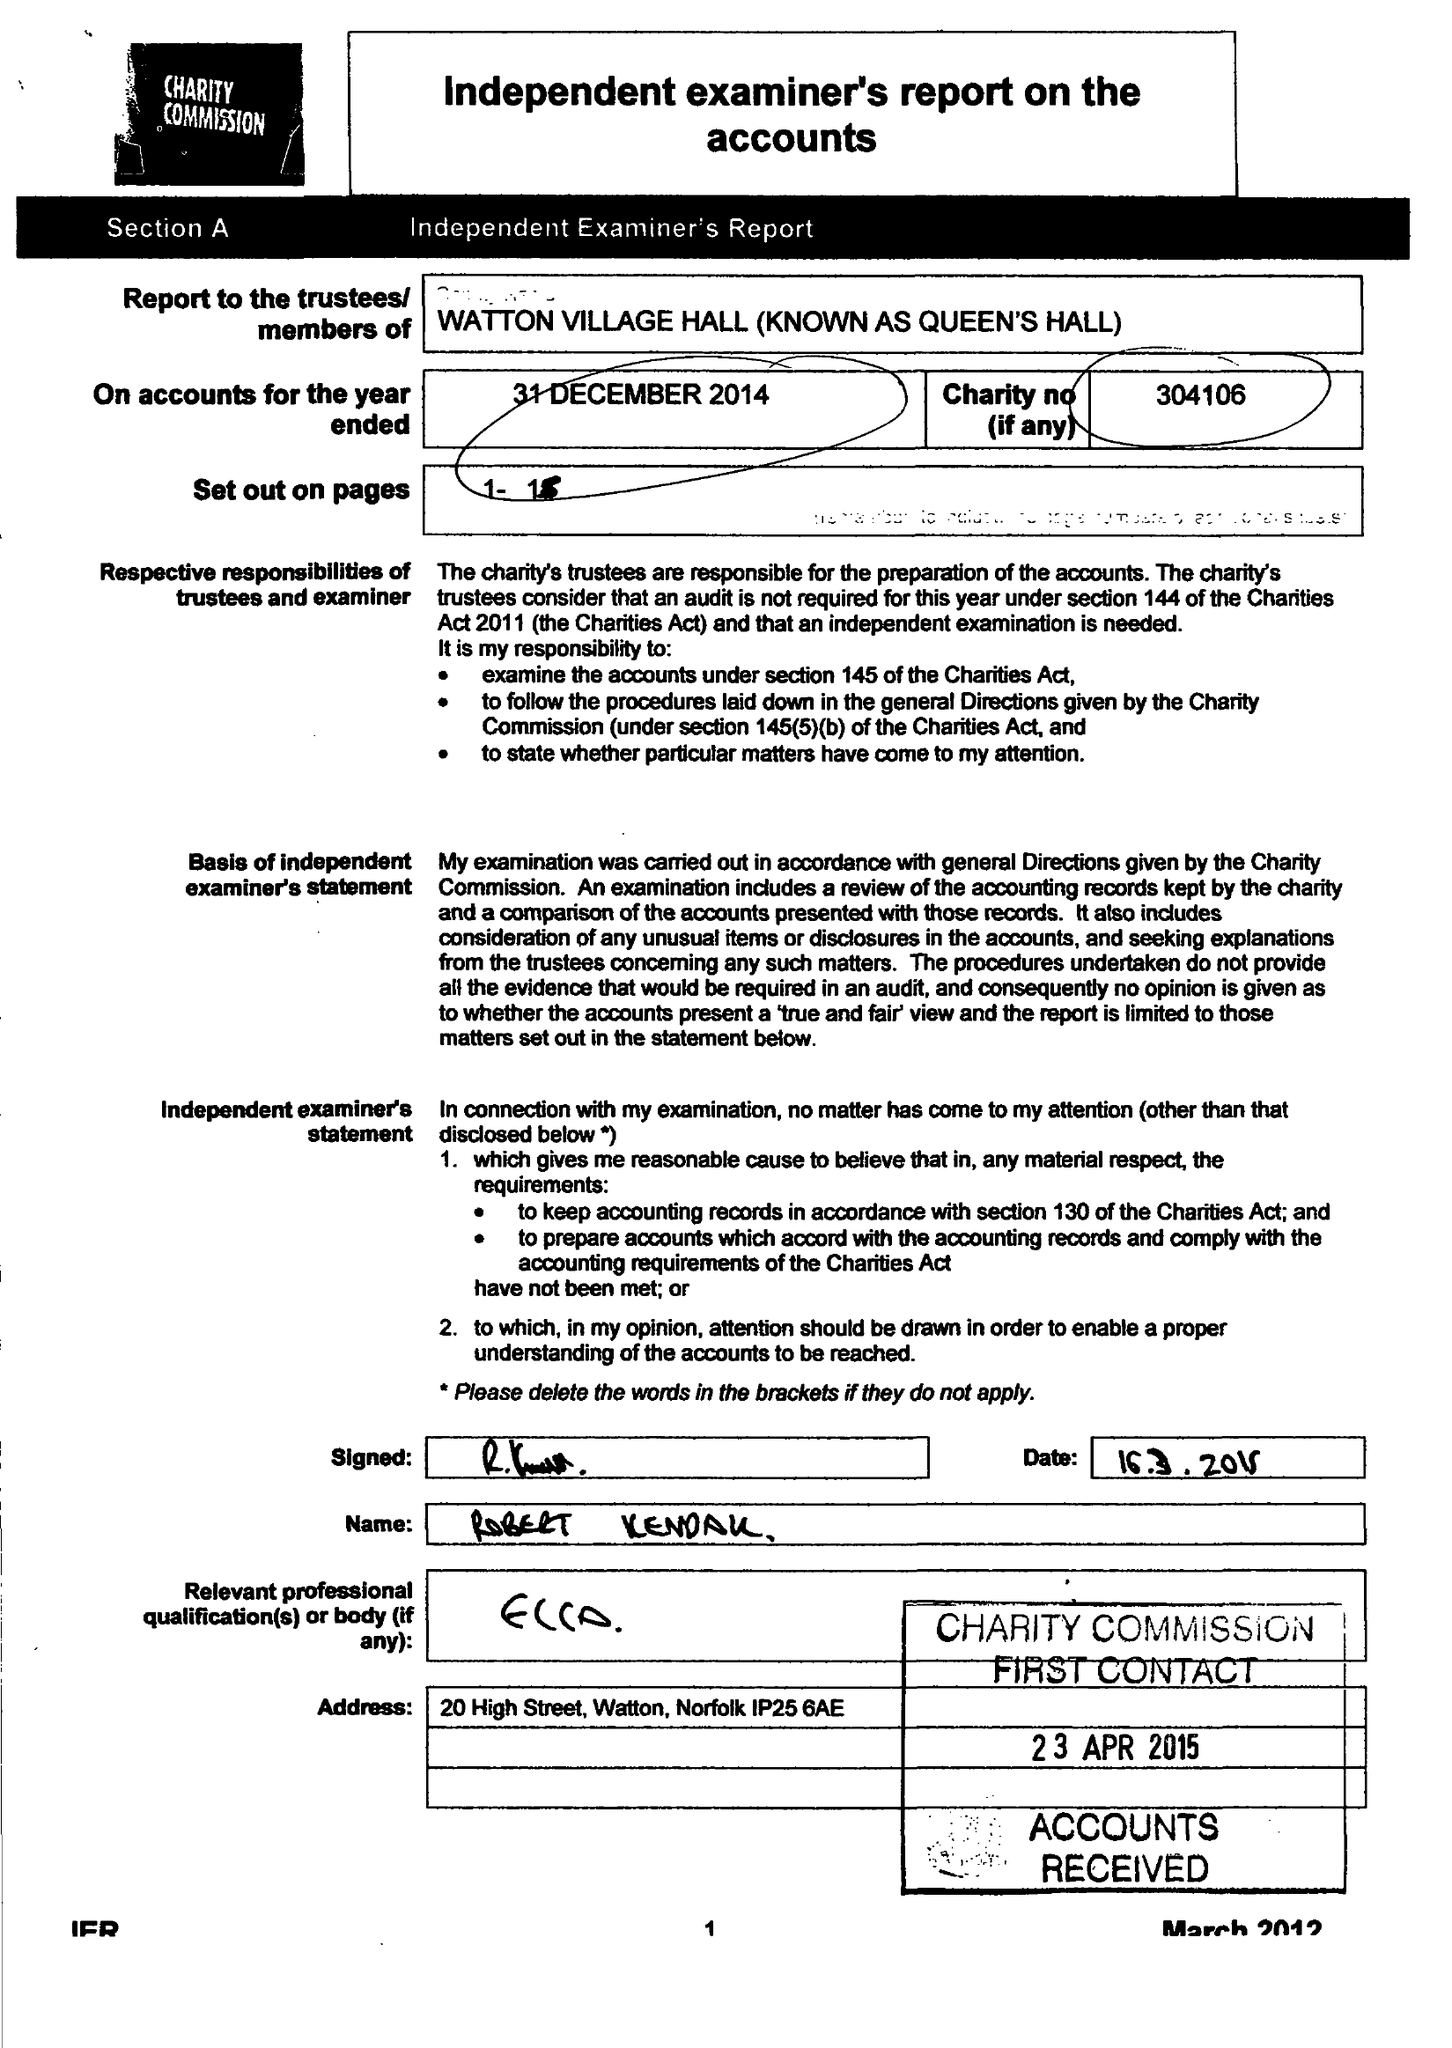What is the value for the address__postcode?
Answer the question using a single word or phrase. IP25 6UT 